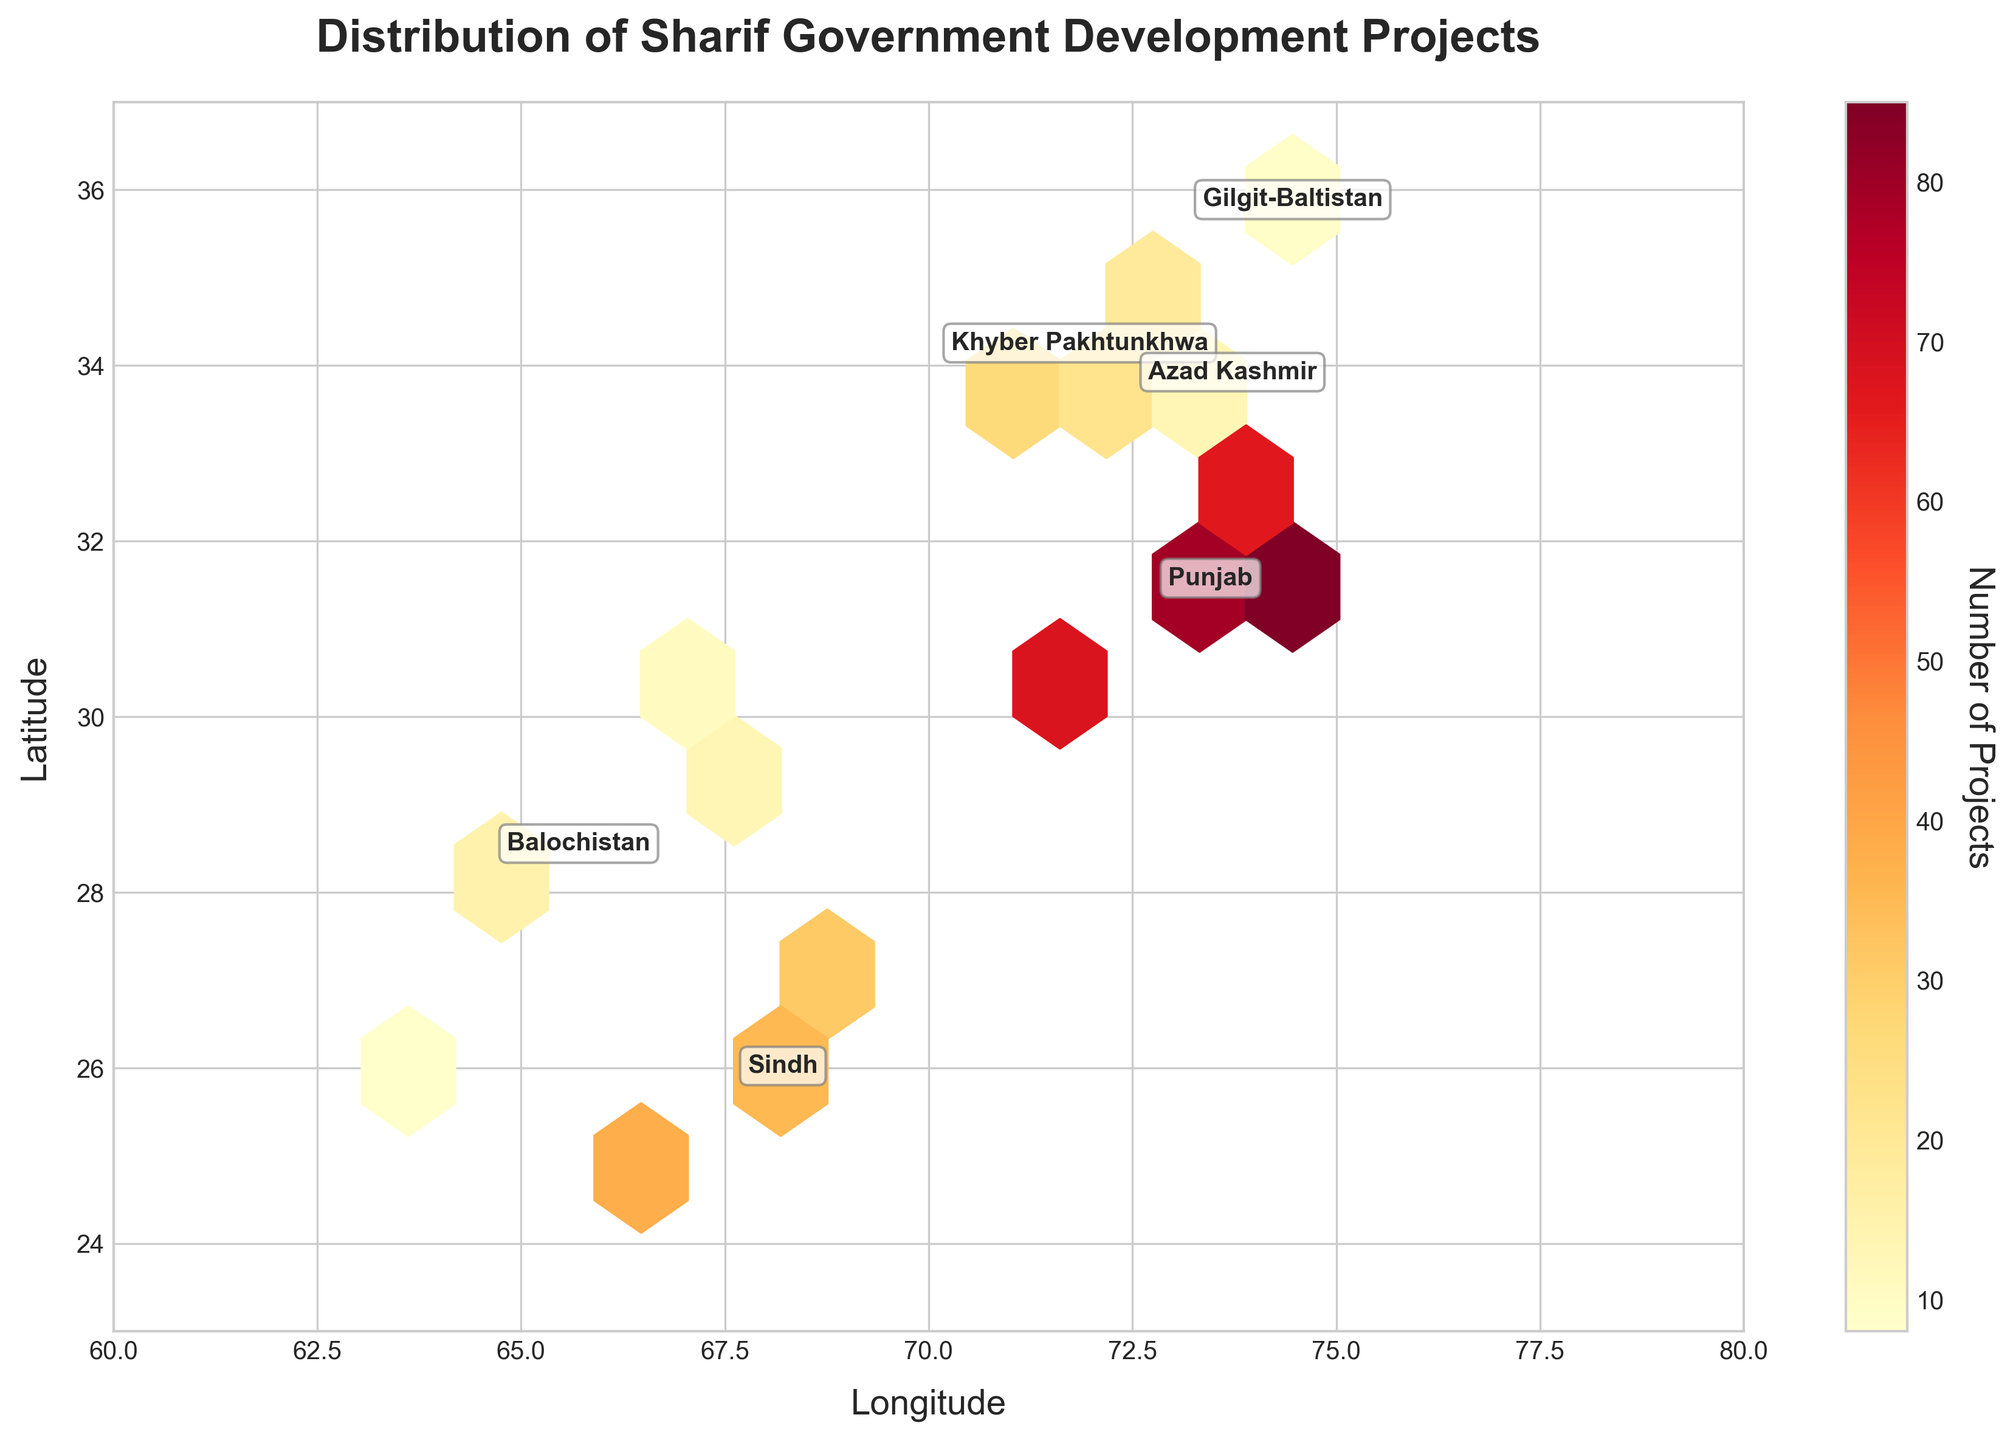Which province has the highest concentration of development projects? Look for the province labeled on the plot with the densest and most colorful hexagons. The highlighted and labeled area with the highest count of projects indicates the province with the highest concentration.
Answer: Punjab How does the number of projects in Sindh compare to that in Punjab? Identify the hexbin colors within the regions labeled as Punjab and Sindh. Punjab shows denser and darker colored hexagons indicating a higher number of projects compared to the lighter colors in Sindh.
Answer: Punjab has more projects than Sindh Which province shows the least concentration of development projects? Check the hexagons corresponding to each labeled province to find the area with the lightest colors or fewest hexagons. This represents the area with the least concentration of projects.
Answer: Gilgit-Baltistan What is the approximate range of latitudes covered by the development projects? Observe the y-axis (latitude) labels on the hexbin plot to determine the range from the topmost to the bottommost hexagon filled with color.
Answer: 23 to 37 degrees Is there a province where projects are more evenly spread out than in others? Look for provinces where the hexagons have a more uniform distribution, indicated by a relatively consistent color across the hexbins within the province area, compared to clusters in other provinces.
Answer: Sindh What does the color gradient in the hexagons signify? Reference the colorbar label on the right side of the plot which describes what the colors represent.
Answer: Number of projects Are there more development projects concentrated in northern or southern Pakistan? Evaluate the distribution of hexagons above and below the mid-latitude range in the plot. More intense and numerous hexagons above the midpoint suggest more projects in the north, and vice versa.
Answer: Northern Pakistan Which regions have moderate project concentrations? Look for provinces where the hexagons show medium intensity colors, not the darkest or lightest, indicating moderate project counts.
Answer: Azad Kashmir, Balochistan What feature helps in identifying the specific provinces on the plot? Notice the text annotations labeling each province directly on the plot, as these assist in identifying regions.
Answer: Annotations Are development projects clustered around specific geographical coordinates? Identify areas with a higher density of hexagons, which indicates project clustering around particular coordinates. These regions would typically appear more heavily colored.
Answer: Yes 